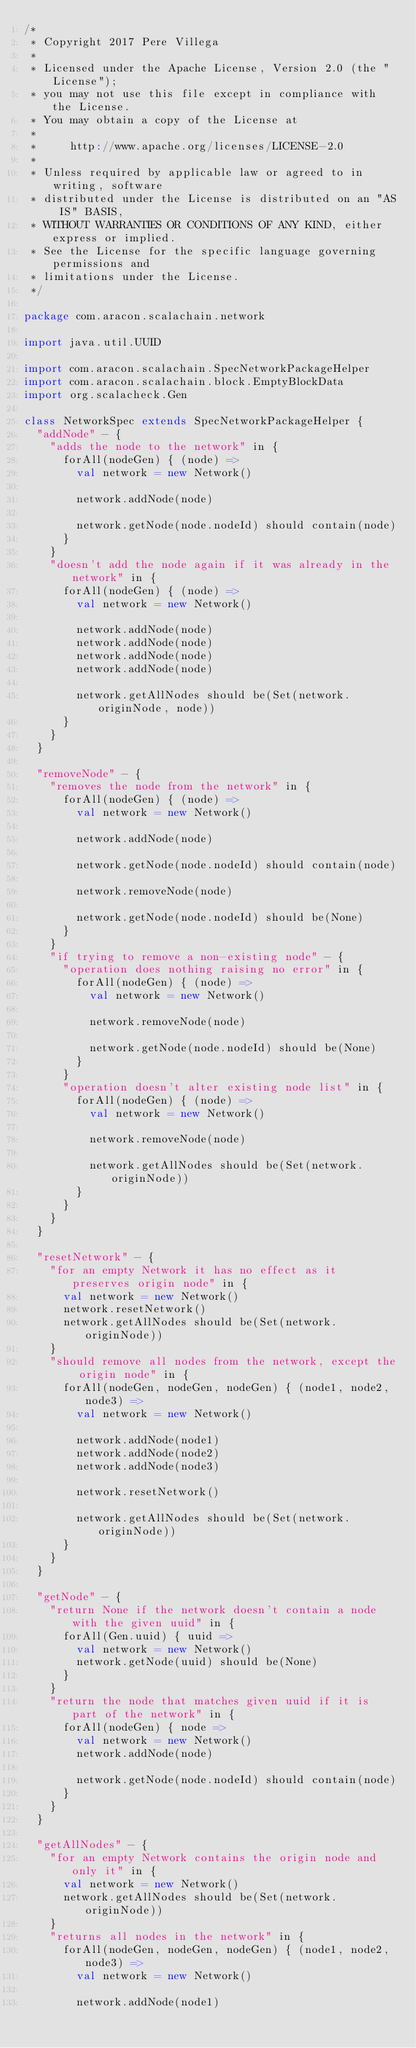Convert code to text. <code><loc_0><loc_0><loc_500><loc_500><_Scala_>/*
 * Copyright 2017 Pere Villega
 *
 * Licensed under the Apache License, Version 2.0 (the "License");
 * you may not use this file except in compliance with the License.
 * You may obtain a copy of the License at
 *
 *     http://www.apache.org/licenses/LICENSE-2.0
 *
 * Unless required by applicable law or agreed to in writing, software
 * distributed under the License is distributed on an "AS IS" BASIS,
 * WITHOUT WARRANTIES OR CONDITIONS OF ANY KIND, either express or implied.
 * See the License for the specific language governing permissions and
 * limitations under the License.
 */

package com.aracon.scalachain.network

import java.util.UUID

import com.aracon.scalachain.SpecNetworkPackageHelper
import com.aracon.scalachain.block.EmptyBlockData
import org.scalacheck.Gen

class NetworkSpec extends SpecNetworkPackageHelper {
  "addNode" - {
    "adds the node to the network" in {
      forAll(nodeGen) { (node) =>
        val network = new Network()

        network.addNode(node)

        network.getNode(node.nodeId) should contain(node)
      }
    }
    "doesn't add the node again if it was already in the network" in {
      forAll(nodeGen) { (node) =>
        val network = new Network()

        network.addNode(node)
        network.addNode(node)
        network.addNode(node)
        network.addNode(node)

        network.getAllNodes should be(Set(network.originNode, node))
      }
    }
  }

  "removeNode" - {
    "removes the node from the network" in {
      forAll(nodeGen) { (node) =>
        val network = new Network()

        network.addNode(node)

        network.getNode(node.nodeId) should contain(node)

        network.removeNode(node)

        network.getNode(node.nodeId) should be(None)
      }
    }
    "if trying to remove a non-existing node" - {
      "operation does nothing raising no error" in {
        forAll(nodeGen) { (node) =>
          val network = new Network()

          network.removeNode(node)

          network.getNode(node.nodeId) should be(None)
        }
      }
      "operation doesn't alter existing node list" in {
        forAll(nodeGen) { (node) =>
          val network = new Network()

          network.removeNode(node)

          network.getAllNodes should be(Set(network.originNode))
        }
      }
    }
  }

  "resetNetwork" - {
    "for an empty Network it has no effect as it preserves origin node" in {
      val network = new Network()
      network.resetNetwork()
      network.getAllNodes should be(Set(network.originNode))
    }
    "should remove all nodes from the network, except the origin node" in {
      forAll(nodeGen, nodeGen, nodeGen) { (node1, node2, node3) =>
        val network = new Network()

        network.addNode(node1)
        network.addNode(node2)
        network.addNode(node3)

        network.resetNetwork()

        network.getAllNodes should be(Set(network.originNode))
      }
    }
  }

  "getNode" - {
    "return None if the network doesn't contain a node with the given uuid" in {
      forAll(Gen.uuid) { uuid =>
        val network = new Network()
        network.getNode(uuid) should be(None)
      }
    }
    "return the node that matches given uuid if it is part of the network" in {
      forAll(nodeGen) { node =>
        val network = new Network()
        network.addNode(node)

        network.getNode(node.nodeId) should contain(node)
      }
    }
  }

  "getAllNodes" - {
    "for an empty Network contains the origin node and only it" in {
      val network = new Network()
      network.getAllNodes should be(Set(network.originNode))
    }
    "returns all nodes in the network" in {
      forAll(nodeGen, nodeGen, nodeGen) { (node1, node2, node3) =>
        val network = new Network()

        network.addNode(node1)</code> 